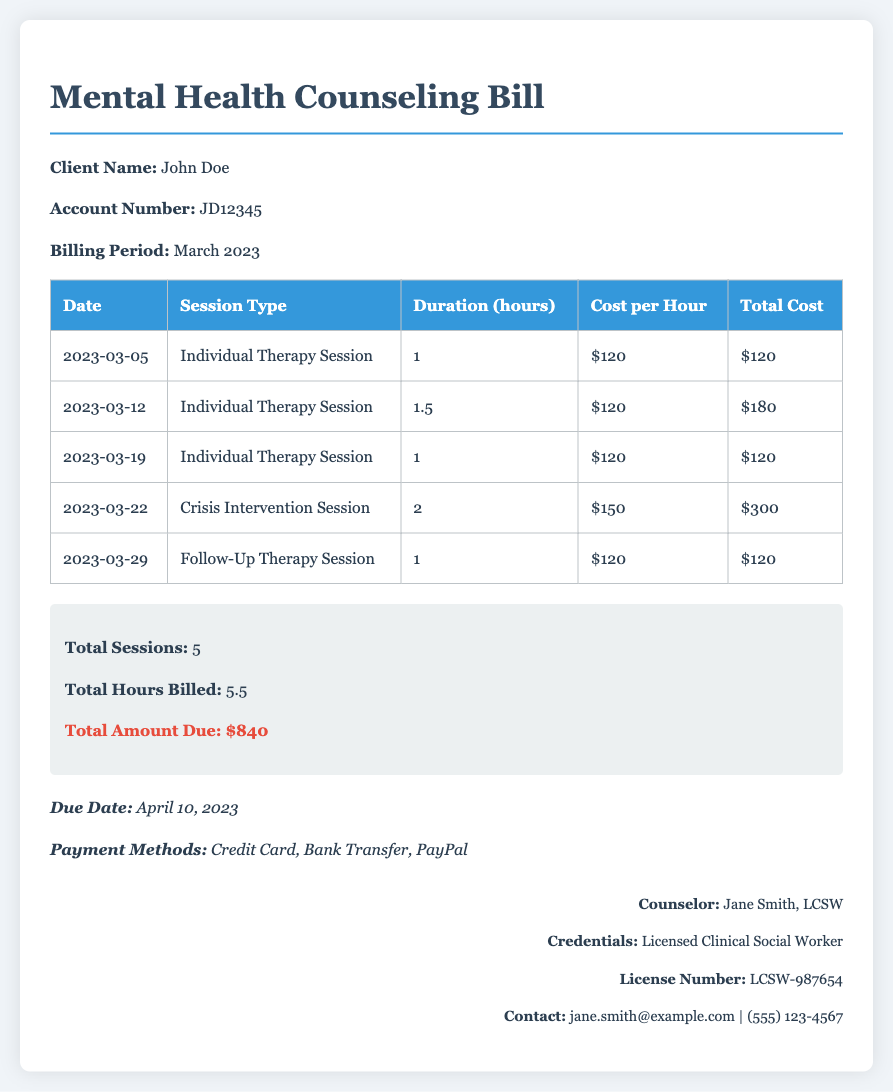What is the client’s name? The document states the client's name is John Doe.
Answer: John Doe What is the account number? The account number provided in the document is JD12345.
Answer: JD12345 How many total sessions were billed? The summary section indicates there were a total of 5 sessions billed.
Answer: 5 What is the total amount due? The total amount due mentioned in the summary is $840.
Answer: $840 What is the duration of the crisis intervention session? The document lists the duration of the crisis intervention session as 2 hours.
Answer: 2 How many hours of individual therapy were billed? The total hours of individual therapy billed can be calculated as 1 + 1.5 + 1 = 3.5 hours.
Answer: 3.5 Who is the counselor? The document identifies the counselor as Jane Smith, LCSW.
Answer: Jane Smith, LCSW What is the cost per hour for a crisis intervention session? The stated cost per hour for a crisis intervention session is $150.
Answer: $150 What payment methods are accepted? The document lists Credit Card, Bank Transfer, and PayPal as payment methods.
Answer: Credit Card, Bank Transfer, PayPal 